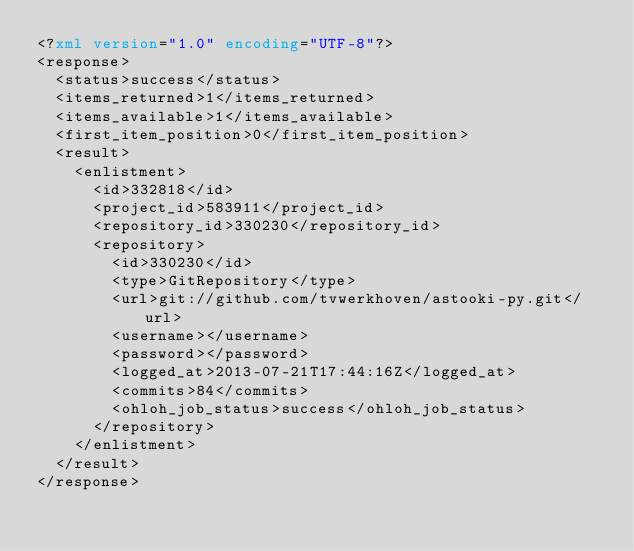Convert code to text. <code><loc_0><loc_0><loc_500><loc_500><_XML_><?xml version="1.0" encoding="UTF-8"?>
<response>
  <status>success</status>
  <items_returned>1</items_returned>
  <items_available>1</items_available>
  <first_item_position>0</first_item_position>
  <result>
    <enlistment>
      <id>332818</id>
      <project_id>583911</project_id>
      <repository_id>330230</repository_id>
      <repository>
        <id>330230</id>
        <type>GitRepository</type>
        <url>git://github.com/tvwerkhoven/astooki-py.git</url>
        <username></username>
        <password></password>
        <logged_at>2013-07-21T17:44:16Z</logged_at>
        <commits>84</commits>
        <ohloh_job_status>success</ohloh_job_status>
      </repository>
    </enlistment>
  </result>
</response>
</code> 